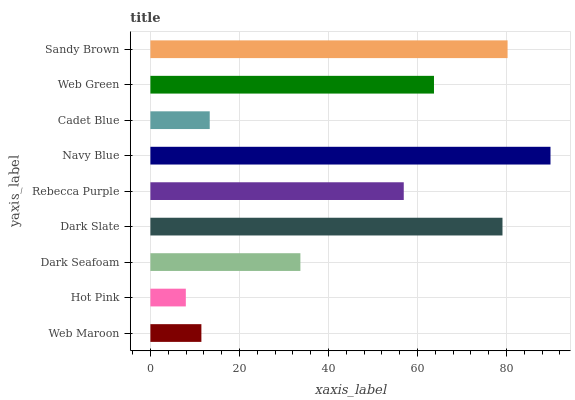Is Hot Pink the minimum?
Answer yes or no. Yes. Is Navy Blue the maximum?
Answer yes or no. Yes. Is Dark Seafoam the minimum?
Answer yes or no. No. Is Dark Seafoam the maximum?
Answer yes or no. No. Is Dark Seafoam greater than Hot Pink?
Answer yes or no. Yes. Is Hot Pink less than Dark Seafoam?
Answer yes or no. Yes. Is Hot Pink greater than Dark Seafoam?
Answer yes or no. No. Is Dark Seafoam less than Hot Pink?
Answer yes or no. No. Is Rebecca Purple the high median?
Answer yes or no. Yes. Is Rebecca Purple the low median?
Answer yes or no. Yes. Is Cadet Blue the high median?
Answer yes or no. No. Is Cadet Blue the low median?
Answer yes or no. No. 